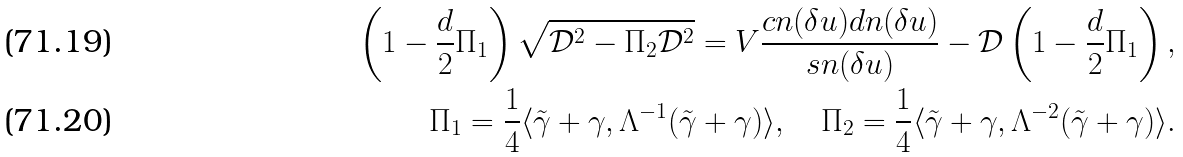<formula> <loc_0><loc_0><loc_500><loc_500>\left ( 1 - \frac { d } { 2 } { \Pi _ { 1 } } \right ) \sqrt { { \mathcal { D } } ^ { 2 } - \Pi _ { 2 } { \mathcal { D } } ^ { 2 } } = V \frac { c n ( \delta u ) d n ( \delta u ) } { s n ( \delta u ) } - { \mathcal { D } } \left ( 1 - \frac { d } { 2 } { \Pi _ { 1 } } \right ) , \\ \Pi _ { 1 } = \frac { 1 } { 4 } \langle \tilde { \gamma } + \gamma , { \Lambda } ^ { - 1 } ( \tilde { \gamma } + \gamma ) \rangle , \quad \Pi _ { 2 } = \frac { 1 } { 4 } \langle \tilde { \gamma } + \gamma , { \Lambda } ^ { - 2 } ( \tilde { \gamma } + \gamma ) \rangle .</formula> 